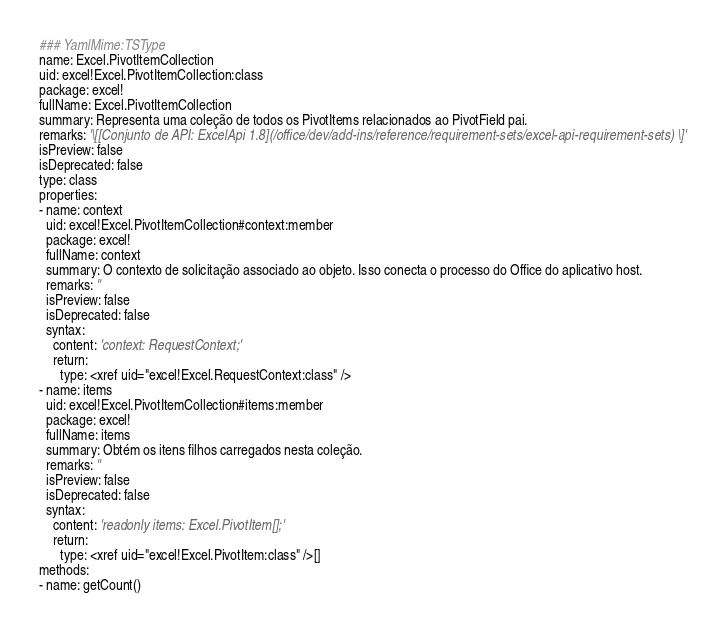<code> <loc_0><loc_0><loc_500><loc_500><_YAML_>### YamlMime:TSType
name: Excel.PivotItemCollection
uid: excel!Excel.PivotItemCollection:class
package: excel!
fullName: Excel.PivotItemCollection
summary: Representa uma coleção de todos os PivotItems relacionados ao PivotField pai.
remarks: '\[[Conjunto de API: ExcelApi 1.8](/office/dev/add-ins/reference/requirement-sets/excel-api-requirement-sets) \]'
isPreview: false
isDeprecated: false
type: class
properties:
- name: context
  uid: excel!Excel.PivotItemCollection#context:member
  package: excel!
  fullName: context
  summary: O contexto de solicitação associado ao objeto. Isso conecta o processo do Office do aplicativo host.
  remarks: ''
  isPreview: false
  isDeprecated: false
  syntax:
    content: 'context: RequestContext;'
    return:
      type: <xref uid="excel!Excel.RequestContext:class" />
- name: items
  uid: excel!Excel.PivotItemCollection#items:member
  package: excel!
  fullName: items
  summary: Obtém os itens filhos carregados nesta coleção.
  remarks: ''
  isPreview: false
  isDeprecated: false
  syntax:
    content: 'readonly items: Excel.PivotItem[];'
    return:
      type: <xref uid="excel!Excel.PivotItem:class" />[]
methods:
- name: getCount()</code> 